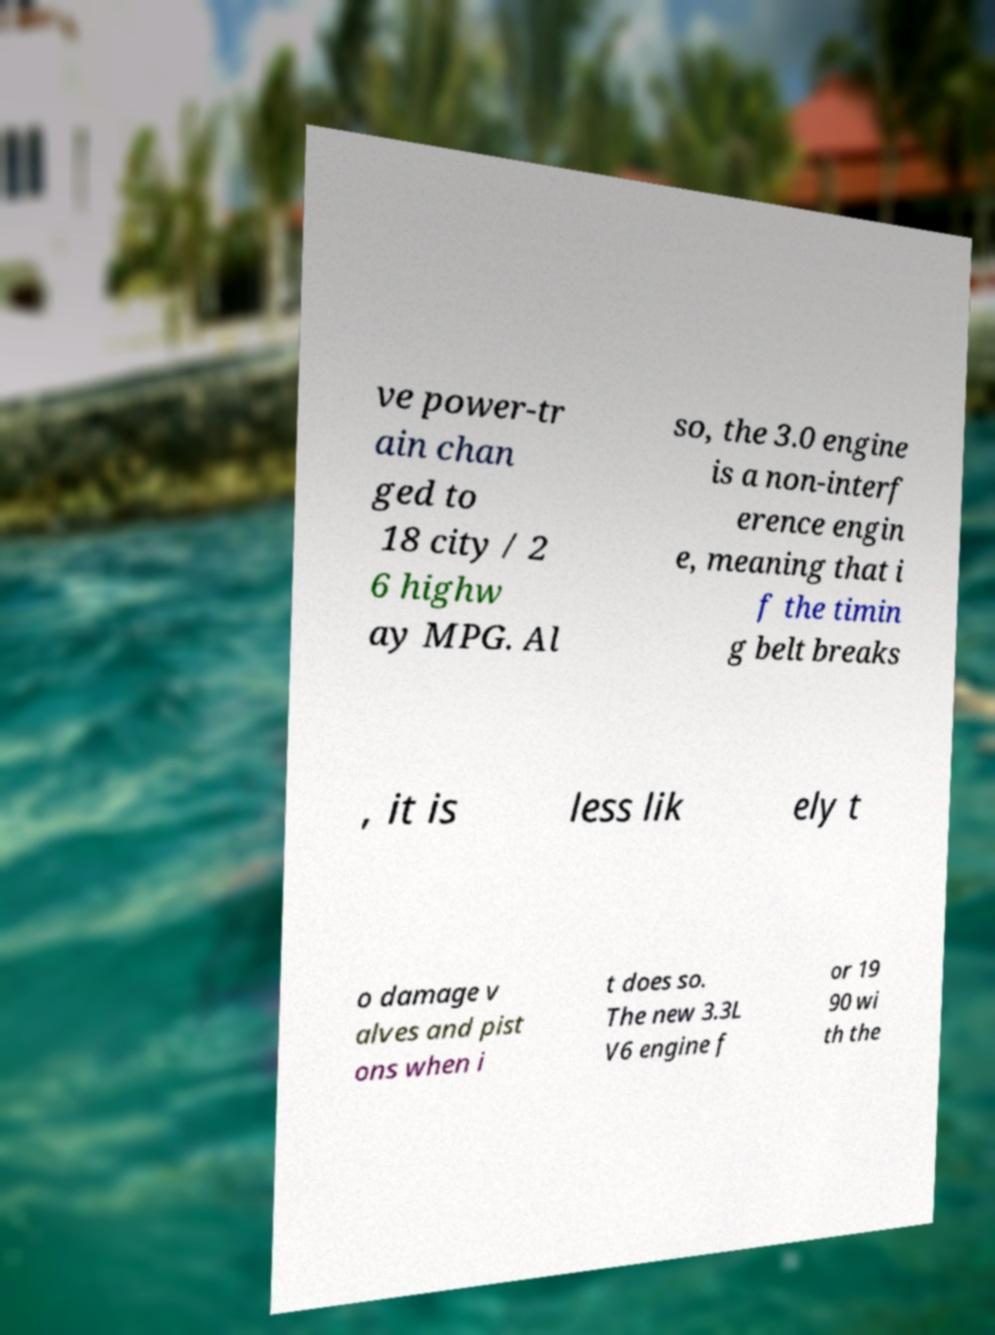What messages or text are displayed in this image? I need them in a readable, typed format. ve power-tr ain chan ged to 18 city / 2 6 highw ay MPG. Al so, the 3.0 engine is a non-interf erence engin e, meaning that i f the timin g belt breaks , it is less lik ely t o damage v alves and pist ons when i t does so. The new 3.3L V6 engine f or 19 90 wi th the 